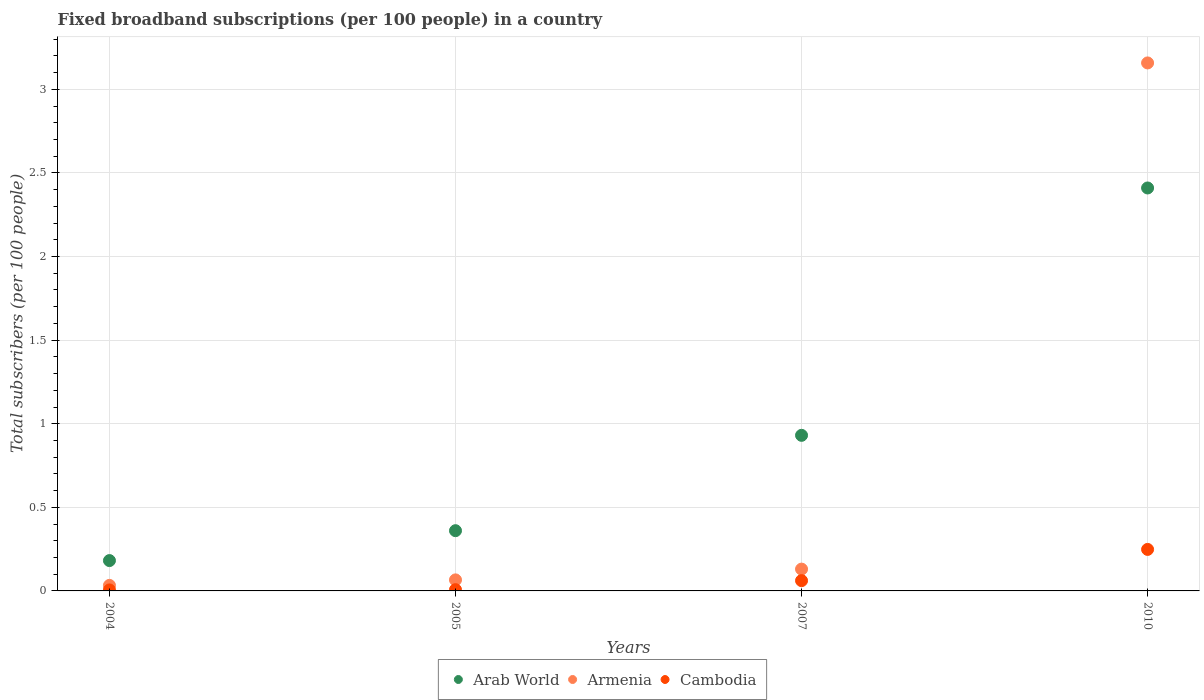What is the number of broadband subscriptions in Cambodia in 2004?
Offer a terse response. 0.01. Across all years, what is the maximum number of broadband subscriptions in Cambodia?
Your answer should be compact. 0.25. Across all years, what is the minimum number of broadband subscriptions in Arab World?
Your answer should be very brief. 0.18. What is the total number of broadband subscriptions in Cambodia in the graph?
Make the answer very short. 0.32. What is the difference between the number of broadband subscriptions in Cambodia in 2004 and that in 2007?
Provide a succinct answer. -0.06. What is the difference between the number of broadband subscriptions in Armenia in 2005 and the number of broadband subscriptions in Cambodia in 2007?
Provide a short and direct response. 0. What is the average number of broadband subscriptions in Cambodia per year?
Offer a very short reply. 0.08. In the year 2005, what is the difference between the number of broadband subscriptions in Armenia and number of broadband subscriptions in Cambodia?
Offer a terse response. 0.06. What is the ratio of the number of broadband subscriptions in Cambodia in 2007 to that in 2010?
Keep it short and to the point. 0.25. Is the difference between the number of broadband subscriptions in Armenia in 2004 and 2005 greater than the difference between the number of broadband subscriptions in Cambodia in 2004 and 2005?
Keep it short and to the point. No. What is the difference between the highest and the second highest number of broadband subscriptions in Armenia?
Ensure brevity in your answer.  3.03. What is the difference between the highest and the lowest number of broadband subscriptions in Arab World?
Provide a succinct answer. 2.23. In how many years, is the number of broadband subscriptions in Arab World greater than the average number of broadband subscriptions in Arab World taken over all years?
Ensure brevity in your answer.  1. Is the number of broadband subscriptions in Cambodia strictly greater than the number of broadband subscriptions in Armenia over the years?
Your answer should be very brief. No. Are the values on the major ticks of Y-axis written in scientific E-notation?
Provide a succinct answer. No. Does the graph contain grids?
Offer a very short reply. Yes. How many legend labels are there?
Your answer should be very brief. 3. What is the title of the graph?
Your answer should be very brief. Fixed broadband subscriptions (per 100 people) in a country. Does "Ireland" appear as one of the legend labels in the graph?
Keep it short and to the point. No. What is the label or title of the Y-axis?
Your answer should be very brief. Total subscribers (per 100 people). What is the Total subscribers (per 100 people) of Arab World in 2004?
Give a very brief answer. 0.18. What is the Total subscribers (per 100 people) of Armenia in 2004?
Your answer should be very brief. 0.03. What is the Total subscribers (per 100 people) in Cambodia in 2004?
Make the answer very short. 0.01. What is the Total subscribers (per 100 people) of Arab World in 2005?
Ensure brevity in your answer.  0.36. What is the Total subscribers (per 100 people) in Armenia in 2005?
Offer a terse response. 0.07. What is the Total subscribers (per 100 people) of Cambodia in 2005?
Provide a succinct answer. 0.01. What is the Total subscribers (per 100 people) of Arab World in 2007?
Your response must be concise. 0.93. What is the Total subscribers (per 100 people) in Armenia in 2007?
Your answer should be compact. 0.13. What is the Total subscribers (per 100 people) of Cambodia in 2007?
Give a very brief answer. 0.06. What is the Total subscribers (per 100 people) in Arab World in 2010?
Give a very brief answer. 2.41. What is the Total subscribers (per 100 people) of Armenia in 2010?
Give a very brief answer. 3.16. What is the Total subscribers (per 100 people) in Cambodia in 2010?
Ensure brevity in your answer.  0.25. Across all years, what is the maximum Total subscribers (per 100 people) of Arab World?
Provide a succinct answer. 2.41. Across all years, what is the maximum Total subscribers (per 100 people) of Armenia?
Your answer should be very brief. 3.16. Across all years, what is the maximum Total subscribers (per 100 people) of Cambodia?
Ensure brevity in your answer.  0.25. Across all years, what is the minimum Total subscribers (per 100 people) of Arab World?
Provide a short and direct response. 0.18. Across all years, what is the minimum Total subscribers (per 100 people) in Armenia?
Provide a succinct answer. 0.03. Across all years, what is the minimum Total subscribers (per 100 people) in Cambodia?
Your response must be concise. 0.01. What is the total Total subscribers (per 100 people) in Arab World in the graph?
Your answer should be very brief. 3.88. What is the total Total subscribers (per 100 people) of Armenia in the graph?
Make the answer very short. 3.39. What is the total Total subscribers (per 100 people) of Cambodia in the graph?
Offer a very short reply. 0.32. What is the difference between the Total subscribers (per 100 people) in Arab World in 2004 and that in 2005?
Offer a very short reply. -0.18. What is the difference between the Total subscribers (per 100 people) in Armenia in 2004 and that in 2005?
Offer a terse response. -0.03. What is the difference between the Total subscribers (per 100 people) in Cambodia in 2004 and that in 2005?
Provide a short and direct response. -0. What is the difference between the Total subscribers (per 100 people) of Arab World in 2004 and that in 2007?
Give a very brief answer. -0.75. What is the difference between the Total subscribers (per 100 people) of Armenia in 2004 and that in 2007?
Offer a very short reply. -0.1. What is the difference between the Total subscribers (per 100 people) of Cambodia in 2004 and that in 2007?
Offer a terse response. -0.06. What is the difference between the Total subscribers (per 100 people) of Arab World in 2004 and that in 2010?
Provide a short and direct response. -2.23. What is the difference between the Total subscribers (per 100 people) in Armenia in 2004 and that in 2010?
Offer a very short reply. -3.12. What is the difference between the Total subscribers (per 100 people) of Cambodia in 2004 and that in 2010?
Keep it short and to the point. -0.24. What is the difference between the Total subscribers (per 100 people) of Arab World in 2005 and that in 2007?
Offer a terse response. -0.57. What is the difference between the Total subscribers (per 100 people) in Armenia in 2005 and that in 2007?
Provide a short and direct response. -0.06. What is the difference between the Total subscribers (per 100 people) in Cambodia in 2005 and that in 2007?
Provide a succinct answer. -0.05. What is the difference between the Total subscribers (per 100 people) in Arab World in 2005 and that in 2010?
Give a very brief answer. -2.05. What is the difference between the Total subscribers (per 100 people) of Armenia in 2005 and that in 2010?
Your answer should be compact. -3.09. What is the difference between the Total subscribers (per 100 people) of Cambodia in 2005 and that in 2010?
Give a very brief answer. -0.24. What is the difference between the Total subscribers (per 100 people) in Arab World in 2007 and that in 2010?
Offer a terse response. -1.48. What is the difference between the Total subscribers (per 100 people) of Armenia in 2007 and that in 2010?
Give a very brief answer. -3.03. What is the difference between the Total subscribers (per 100 people) of Cambodia in 2007 and that in 2010?
Your answer should be compact. -0.19. What is the difference between the Total subscribers (per 100 people) in Arab World in 2004 and the Total subscribers (per 100 people) in Armenia in 2005?
Provide a succinct answer. 0.12. What is the difference between the Total subscribers (per 100 people) of Arab World in 2004 and the Total subscribers (per 100 people) of Cambodia in 2005?
Ensure brevity in your answer.  0.17. What is the difference between the Total subscribers (per 100 people) in Armenia in 2004 and the Total subscribers (per 100 people) in Cambodia in 2005?
Keep it short and to the point. 0.03. What is the difference between the Total subscribers (per 100 people) in Arab World in 2004 and the Total subscribers (per 100 people) in Armenia in 2007?
Provide a short and direct response. 0.05. What is the difference between the Total subscribers (per 100 people) in Arab World in 2004 and the Total subscribers (per 100 people) in Cambodia in 2007?
Your response must be concise. 0.12. What is the difference between the Total subscribers (per 100 people) in Armenia in 2004 and the Total subscribers (per 100 people) in Cambodia in 2007?
Ensure brevity in your answer.  -0.03. What is the difference between the Total subscribers (per 100 people) in Arab World in 2004 and the Total subscribers (per 100 people) in Armenia in 2010?
Ensure brevity in your answer.  -2.98. What is the difference between the Total subscribers (per 100 people) of Arab World in 2004 and the Total subscribers (per 100 people) of Cambodia in 2010?
Your answer should be very brief. -0.07. What is the difference between the Total subscribers (per 100 people) in Armenia in 2004 and the Total subscribers (per 100 people) in Cambodia in 2010?
Your answer should be very brief. -0.22. What is the difference between the Total subscribers (per 100 people) in Arab World in 2005 and the Total subscribers (per 100 people) in Armenia in 2007?
Your answer should be compact. 0.23. What is the difference between the Total subscribers (per 100 people) in Arab World in 2005 and the Total subscribers (per 100 people) in Cambodia in 2007?
Ensure brevity in your answer.  0.3. What is the difference between the Total subscribers (per 100 people) in Armenia in 2005 and the Total subscribers (per 100 people) in Cambodia in 2007?
Make the answer very short. 0. What is the difference between the Total subscribers (per 100 people) in Arab World in 2005 and the Total subscribers (per 100 people) in Armenia in 2010?
Offer a very short reply. -2.8. What is the difference between the Total subscribers (per 100 people) in Arab World in 2005 and the Total subscribers (per 100 people) in Cambodia in 2010?
Your answer should be very brief. 0.11. What is the difference between the Total subscribers (per 100 people) of Armenia in 2005 and the Total subscribers (per 100 people) of Cambodia in 2010?
Your response must be concise. -0.18. What is the difference between the Total subscribers (per 100 people) in Arab World in 2007 and the Total subscribers (per 100 people) in Armenia in 2010?
Your answer should be compact. -2.23. What is the difference between the Total subscribers (per 100 people) of Arab World in 2007 and the Total subscribers (per 100 people) of Cambodia in 2010?
Your response must be concise. 0.68. What is the difference between the Total subscribers (per 100 people) in Armenia in 2007 and the Total subscribers (per 100 people) in Cambodia in 2010?
Keep it short and to the point. -0.12. What is the average Total subscribers (per 100 people) in Arab World per year?
Provide a succinct answer. 0.97. What is the average Total subscribers (per 100 people) in Armenia per year?
Provide a short and direct response. 0.85. What is the average Total subscribers (per 100 people) in Cambodia per year?
Ensure brevity in your answer.  0.08. In the year 2004, what is the difference between the Total subscribers (per 100 people) of Arab World and Total subscribers (per 100 people) of Armenia?
Ensure brevity in your answer.  0.15. In the year 2004, what is the difference between the Total subscribers (per 100 people) in Arab World and Total subscribers (per 100 people) in Cambodia?
Your answer should be very brief. 0.18. In the year 2004, what is the difference between the Total subscribers (per 100 people) of Armenia and Total subscribers (per 100 people) of Cambodia?
Give a very brief answer. 0.03. In the year 2005, what is the difference between the Total subscribers (per 100 people) in Arab World and Total subscribers (per 100 people) in Armenia?
Make the answer very short. 0.29. In the year 2005, what is the difference between the Total subscribers (per 100 people) in Arab World and Total subscribers (per 100 people) in Cambodia?
Offer a very short reply. 0.35. In the year 2005, what is the difference between the Total subscribers (per 100 people) in Armenia and Total subscribers (per 100 people) in Cambodia?
Your answer should be very brief. 0.06. In the year 2007, what is the difference between the Total subscribers (per 100 people) of Arab World and Total subscribers (per 100 people) of Armenia?
Your answer should be very brief. 0.8. In the year 2007, what is the difference between the Total subscribers (per 100 people) of Arab World and Total subscribers (per 100 people) of Cambodia?
Your answer should be compact. 0.87. In the year 2007, what is the difference between the Total subscribers (per 100 people) of Armenia and Total subscribers (per 100 people) of Cambodia?
Your answer should be very brief. 0.07. In the year 2010, what is the difference between the Total subscribers (per 100 people) in Arab World and Total subscribers (per 100 people) in Armenia?
Ensure brevity in your answer.  -0.75. In the year 2010, what is the difference between the Total subscribers (per 100 people) in Arab World and Total subscribers (per 100 people) in Cambodia?
Your answer should be compact. 2.16. In the year 2010, what is the difference between the Total subscribers (per 100 people) in Armenia and Total subscribers (per 100 people) in Cambodia?
Provide a succinct answer. 2.91. What is the ratio of the Total subscribers (per 100 people) of Arab World in 2004 to that in 2005?
Ensure brevity in your answer.  0.5. What is the ratio of the Total subscribers (per 100 people) in Armenia in 2004 to that in 2005?
Provide a succinct answer. 0.5. What is the ratio of the Total subscribers (per 100 people) in Cambodia in 2004 to that in 2005?
Ensure brevity in your answer.  0.79. What is the ratio of the Total subscribers (per 100 people) of Arab World in 2004 to that in 2007?
Provide a succinct answer. 0.2. What is the ratio of the Total subscribers (per 100 people) in Armenia in 2004 to that in 2007?
Offer a terse response. 0.25. What is the ratio of the Total subscribers (per 100 people) of Cambodia in 2004 to that in 2007?
Provide a succinct answer. 0.1. What is the ratio of the Total subscribers (per 100 people) in Arab World in 2004 to that in 2010?
Provide a short and direct response. 0.08. What is the ratio of the Total subscribers (per 100 people) of Armenia in 2004 to that in 2010?
Provide a succinct answer. 0.01. What is the ratio of the Total subscribers (per 100 people) in Cambodia in 2004 to that in 2010?
Offer a terse response. 0.02. What is the ratio of the Total subscribers (per 100 people) in Arab World in 2005 to that in 2007?
Ensure brevity in your answer.  0.39. What is the ratio of the Total subscribers (per 100 people) of Armenia in 2005 to that in 2007?
Your answer should be compact. 0.51. What is the ratio of the Total subscribers (per 100 people) in Cambodia in 2005 to that in 2007?
Offer a very short reply. 0.12. What is the ratio of the Total subscribers (per 100 people) in Arab World in 2005 to that in 2010?
Provide a short and direct response. 0.15. What is the ratio of the Total subscribers (per 100 people) in Armenia in 2005 to that in 2010?
Ensure brevity in your answer.  0.02. What is the ratio of the Total subscribers (per 100 people) in Cambodia in 2005 to that in 2010?
Keep it short and to the point. 0.03. What is the ratio of the Total subscribers (per 100 people) in Arab World in 2007 to that in 2010?
Your answer should be very brief. 0.39. What is the ratio of the Total subscribers (per 100 people) in Armenia in 2007 to that in 2010?
Provide a short and direct response. 0.04. What is the ratio of the Total subscribers (per 100 people) in Cambodia in 2007 to that in 2010?
Provide a short and direct response. 0.25. What is the difference between the highest and the second highest Total subscribers (per 100 people) of Arab World?
Ensure brevity in your answer.  1.48. What is the difference between the highest and the second highest Total subscribers (per 100 people) of Armenia?
Provide a short and direct response. 3.03. What is the difference between the highest and the second highest Total subscribers (per 100 people) of Cambodia?
Ensure brevity in your answer.  0.19. What is the difference between the highest and the lowest Total subscribers (per 100 people) of Arab World?
Keep it short and to the point. 2.23. What is the difference between the highest and the lowest Total subscribers (per 100 people) of Armenia?
Provide a short and direct response. 3.12. What is the difference between the highest and the lowest Total subscribers (per 100 people) of Cambodia?
Your answer should be compact. 0.24. 